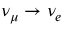Convert formula to latex. <formula><loc_0><loc_0><loc_500><loc_500>\nu _ { \mu } \rightarrow \nu _ { e }</formula> 